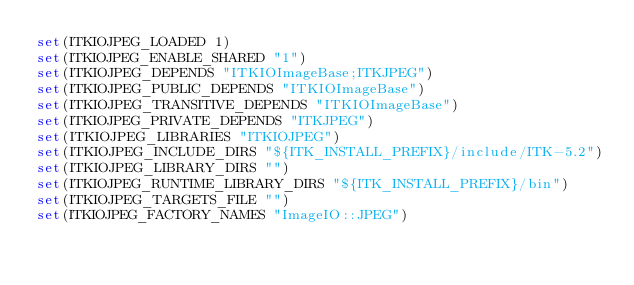Convert code to text. <code><loc_0><loc_0><loc_500><loc_500><_CMake_>set(ITKIOJPEG_LOADED 1)
set(ITKIOJPEG_ENABLE_SHARED "1")
set(ITKIOJPEG_DEPENDS "ITKIOImageBase;ITKJPEG")
set(ITKIOJPEG_PUBLIC_DEPENDS "ITKIOImageBase")
set(ITKIOJPEG_TRANSITIVE_DEPENDS "ITKIOImageBase")
set(ITKIOJPEG_PRIVATE_DEPENDS "ITKJPEG")
set(ITKIOJPEG_LIBRARIES "ITKIOJPEG")
set(ITKIOJPEG_INCLUDE_DIRS "${ITK_INSTALL_PREFIX}/include/ITK-5.2")
set(ITKIOJPEG_LIBRARY_DIRS "")
set(ITKIOJPEG_RUNTIME_LIBRARY_DIRS "${ITK_INSTALL_PREFIX}/bin")
set(ITKIOJPEG_TARGETS_FILE "")
set(ITKIOJPEG_FACTORY_NAMES "ImageIO::JPEG")

</code> 